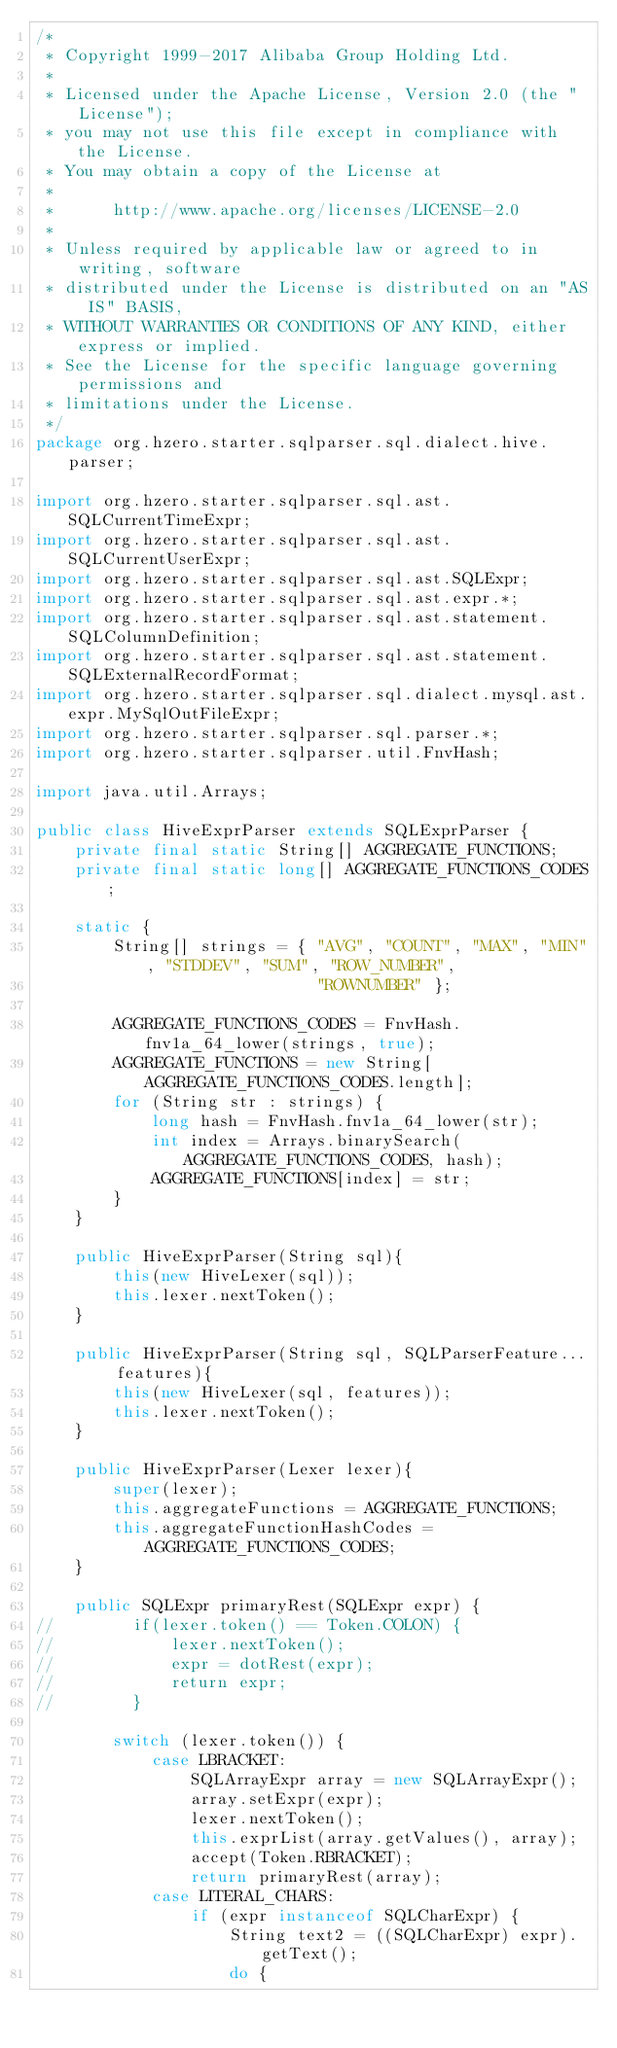Convert code to text. <code><loc_0><loc_0><loc_500><loc_500><_Java_>/*
 * Copyright 1999-2017 Alibaba Group Holding Ltd.
 *
 * Licensed under the Apache License, Version 2.0 (the "License");
 * you may not use this file except in compliance with the License.
 * You may obtain a copy of the License at
 *
 *      http://www.apache.org/licenses/LICENSE-2.0
 *
 * Unless required by applicable law or agreed to in writing, software
 * distributed under the License is distributed on an "AS IS" BASIS,
 * WITHOUT WARRANTIES OR CONDITIONS OF ANY KIND, either express or implied.
 * See the License for the specific language governing permissions and
 * limitations under the License.
 */
package org.hzero.starter.sqlparser.sql.dialect.hive.parser;

import org.hzero.starter.sqlparser.sql.ast.SQLCurrentTimeExpr;
import org.hzero.starter.sqlparser.sql.ast.SQLCurrentUserExpr;
import org.hzero.starter.sqlparser.sql.ast.SQLExpr;
import org.hzero.starter.sqlparser.sql.ast.expr.*;
import org.hzero.starter.sqlparser.sql.ast.statement.SQLColumnDefinition;
import org.hzero.starter.sqlparser.sql.ast.statement.SQLExternalRecordFormat;
import org.hzero.starter.sqlparser.sql.dialect.mysql.ast.expr.MySqlOutFileExpr;
import org.hzero.starter.sqlparser.sql.parser.*;
import org.hzero.starter.sqlparser.util.FnvHash;

import java.util.Arrays;

public class HiveExprParser extends SQLExprParser {
    private final static String[] AGGREGATE_FUNCTIONS;
    private final static long[] AGGREGATE_FUNCTIONS_CODES;

    static {
        String[] strings = { "AVG", "COUNT", "MAX", "MIN", "STDDEV", "SUM", "ROW_NUMBER",
                             "ROWNUMBER" };

        AGGREGATE_FUNCTIONS_CODES = FnvHash.fnv1a_64_lower(strings, true);
        AGGREGATE_FUNCTIONS = new String[AGGREGATE_FUNCTIONS_CODES.length];
        for (String str : strings) {
            long hash = FnvHash.fnv1a_64_lower(str);
            int index = Arrays.binarySearch(AGGREGATE_FUNCTIONS_CODES, hash);
            AGGREGATE_FUNCTIONS[index] = str;
        }
    }

    public HiveExprParser(String sql){
        this(new HiveLexer(sql));
        this.lexer.nextToken();
    }

    public HiveExprParser(String sql, SQLParserFeature... features){
        this(new HiveLexer(sql, features));
        this.lexer.nextToken();
    }

    public HiveExprParser(Lexer lexer){
        super(lexer);
        this.aggregateFunctions = AGGREGATE_FUNCTIONS;
        this.aggregateFunctionHashCodes = AGGREGATE_FUNCTIONS_CODES;
    }

    public SQLExpr primaryRest(SQLExpr expr) {
//        if(lexer.token() == Token.COLON) {
//            lexer.nextToken();
//            expr = dotRest(expr);
//            return expr;
//        }

        switch (lexer.token()) {
            case LBRACKET:
                SQLArrayExpr array = new SQLArrayExpr();
                array.setExpr(expr);
                lexer.nextToken();
                this.exprList(array.getValues(), array);
                accept(Token.RBRACKET);
                return primaryRest(array);
            case LITERAL_CHARS:
                if (expr instanceof SQLCharExpr) {
                    String text2 = ((SQLCharExpr) expr).getText();
                    do {</code> 